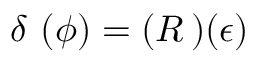<formula> <loc_0><loc_0><loc_500><loc_500>\delta \, ( \phi ) = ( R \, ) ( \epsilon )</formula> 